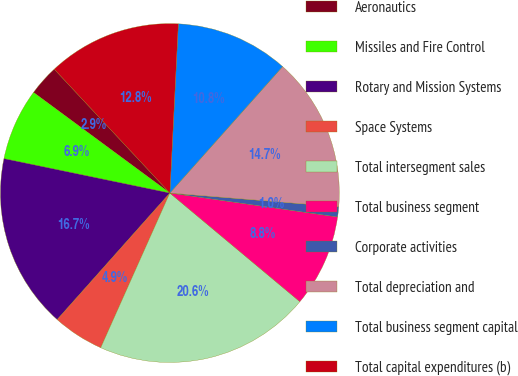<chart> <loc_0><loc_0><loc_500><loc_500><pie_chart><fcel>Aeronautics<fcel>Missiles and Fire Control<fcel>Rotary and Mission Systems<fcel>Space Systems<fcel>Total intersegment sales<fcel>Total business segment<fcel>Corporate activities<fcel>Total depreciation and<fcel>Total business segment capital<fcel>Total capital expenditures (b)<nl><fcel>2.93%<fcel>6.86%<fcel>16.68%<fcel>4.89%<fcel>20.61%<fcel>8.82%<fcel>0.96%<fcel>14.71%<fcel>10.79%<fcel>12.75%<nl></chart> 